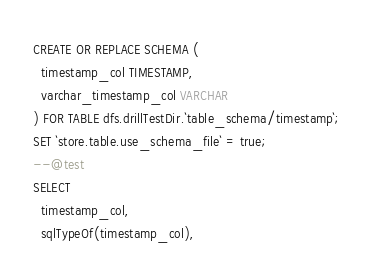Convert code to text. <code><loc_0><loc_0><loc_500><loc_500><_SQL_>CREATE OR REPLACE SCHEMA (
  timestamp_col TIMESTAMP,
  varchar_timestamp_col VARCHAR
) FOR TABLE dfs.drillTestDir.`table_schema/timestamp`;
SET `store.table.use_schema_file` = true;
--@test
SELECT
  timestamp_col,
  sqlTypeOf(timestamp_col),</code> 